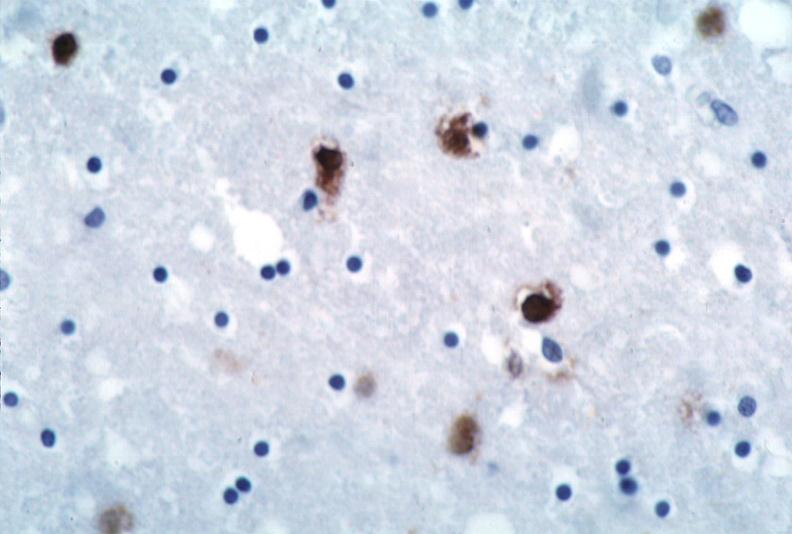s nervous present?
Answer the question using a single word or phrase. Yes 